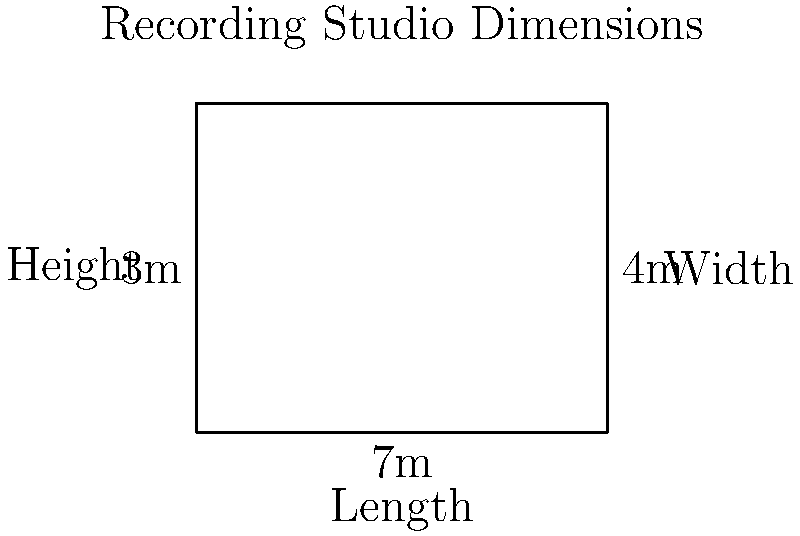You're designing a rectangular home recording studio with dimensions 7m (length) x 4m (width) x 3m (height). Calculate the frequency of the first axial room mode along the length of the studio. Use the speed of sound as 343 m/s. To calculate the frequency of the first axial room mode along the length of the studio, we'll follow these steps:

1) The formula for calculating axial room modes is:

   $$ f = \frac{c}{2L} \sqrt{(\frac{n_x}{L_x})^2 + (\frac{n_y}{L_y})^2 + (\frac{n_z}{L_z})^2} $$

   Where:
   $f$ = frequency of the room mode
   $c$ = speed of sound (343 m/s)
   $L_x$, $L_y$, $L_z$ = room dimensions
   $n_x$, $n_y$, $n_z$ = mode numbers (integers)

2) For the first axial mode along the length:
   $n_x = 1$, $n_y = 0$, $n_z = 0$
   $L_x = 7$ m (length)

3) Simplifying the equation:

   $$ f = \frac{343}{2(7)} \sqrt{(\frac{1}{7})^2 + 0 + 0} = \frac{343}{14} \cdot \frac{1}{7} $$

4) Calculate:

   $$ f = \frac{343}{14 \cdot 7} = \frac{343}{98} \approx 24.5 \text{ Hz} $$

Thus, the frequency of the first axial room mode along the length of the studio is approximately 24.5 Hz.
Answer: 24.5 Hz 